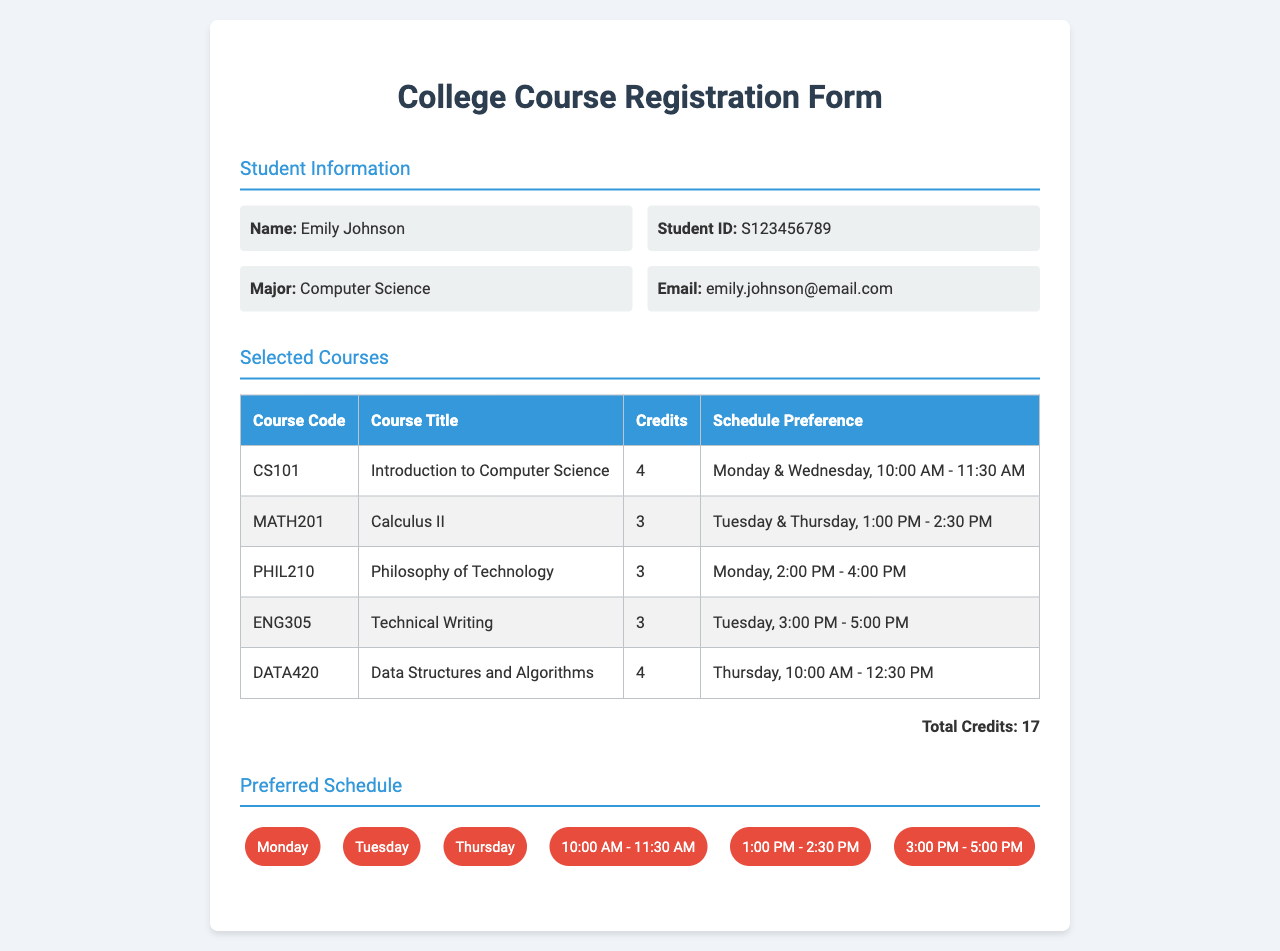what is the name of the student? The student's name is provided in the document.
Answer: Emily Johnson what is the student ID? The student ID is a unique identifier shown in the document.
Answer: S123456789 how many total credits are selected? The total credits are calculated based on the courses listed in the document.
Answer: 17 which course has the code CS101? The course title corresponding to the code CS101 is mentioned in the document.
Answer: Introduction to Computer Science when is the Philosophy of Technology course scheduled? The schedule for this course can be found in the course details section.
Answer: Monday, 2:00 PM - 4:00 PM which course is scheduled on Tuesday afternoon? This refers to the courses listed with their respective schedules.
Answer: Technical Writing what are the preferred days for classes? The preferred schedule includes specific days listed in the document.
Answer: Monday, Tuesday, Thursday how many hours is the Introduction to Computer Science course? The number of credits often indicates the hours of the course per week.
Answer: 4 what is the email address of the student? The email address is included in the student information section of the document.
Answer: emily.johnson@email.com 